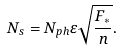<formula> <loc_0><loc_0><loc_500><loc_500>N _ { s } = N _ { p h } \varepsilon \sqrt { \frac { F _ { * } } { n } } .</formula> 